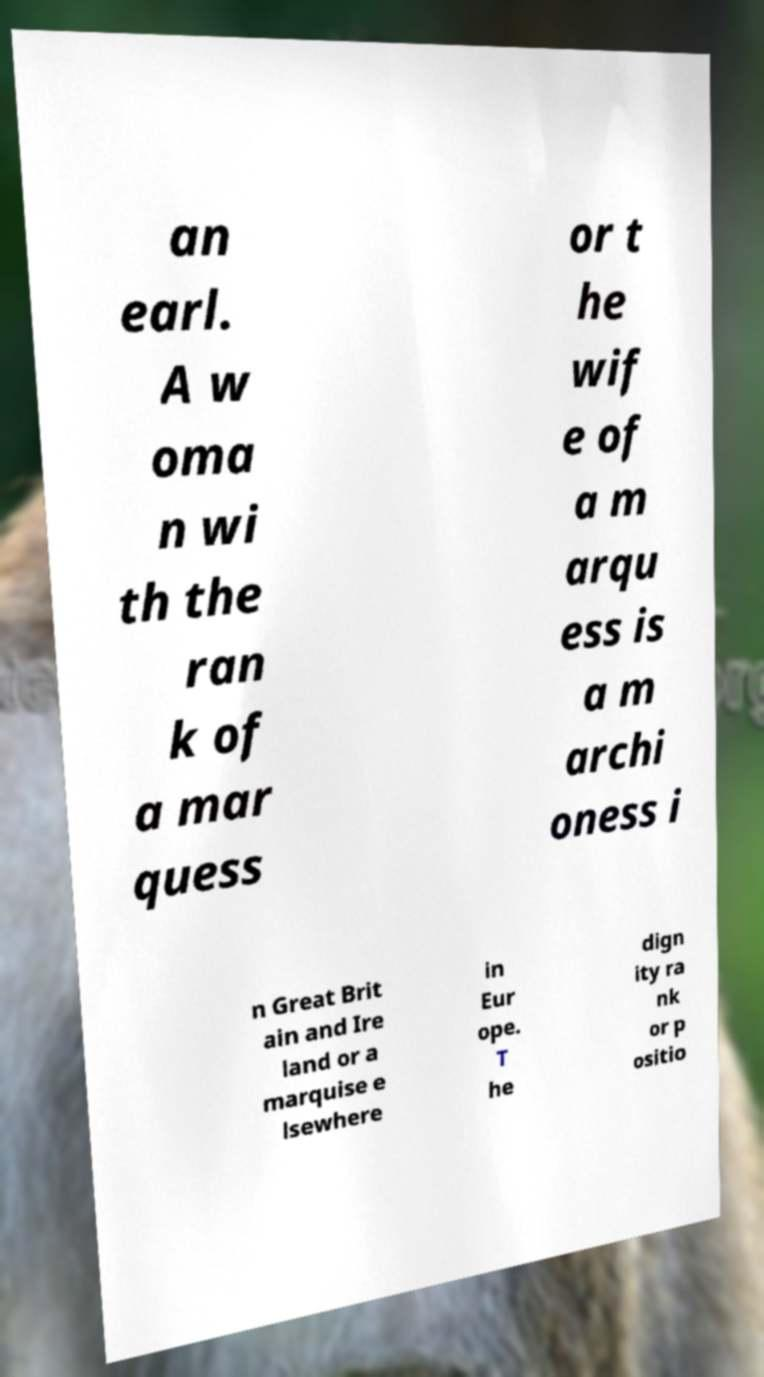Can you read and provide the text displayed in the image?This photo seems to have some interesting text. Can you extract and type it out for me? an earl. A w oma n wi th the ran k of a mar quess or t he wif e of a m arqu ess is a m archi oness i n Great Brit ain and Ire land or a marquise e lsewhere in Eur ope. T he dign ity ra nk or p ositio 